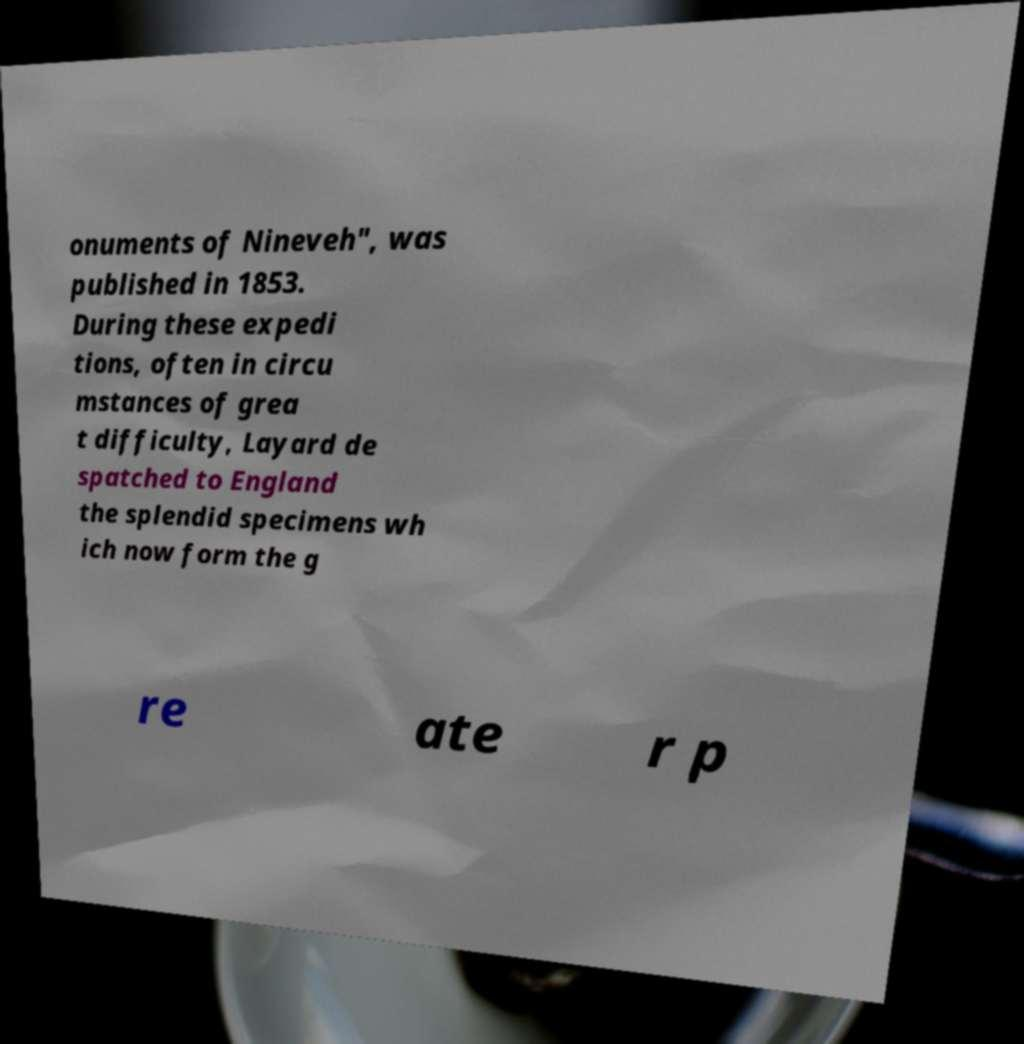Can you accurately transcribe the text from the provided image for me? onuments of Nineveh", was published in 1853. During these expedi tions, often in circu mstances of grea t difficulty, Layard de spatched to England the splendid specimens wh ich now form the g re ate r p 